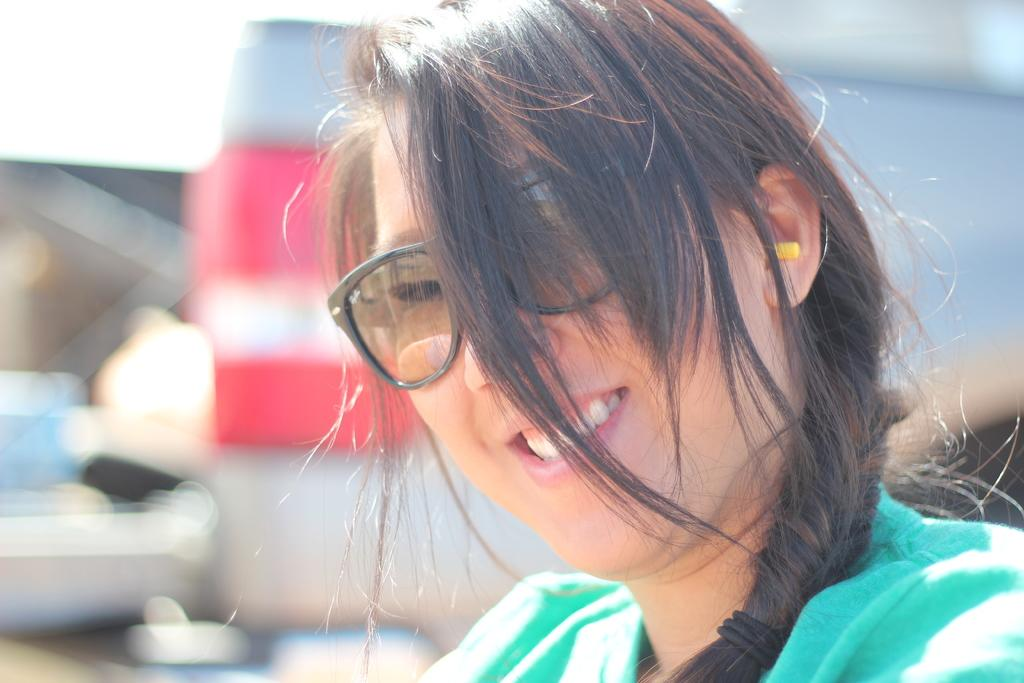What is the main subject of the image? The main subject of the image is a woman. What can be observed about the woman's appearance? The woman is wearing spectacles. What is the woman's facial expression in the image? The woman is smiling. What type of engine can be seen in the image? There is no engine present in the image; it features a woman wearing spectacles and smiling. 